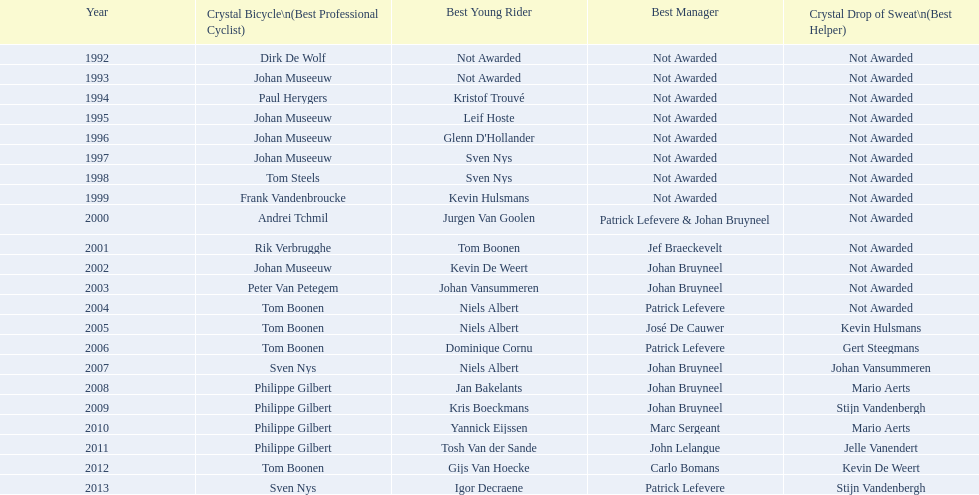How many times, on average, did johan museeuw appear as a star? 5. 